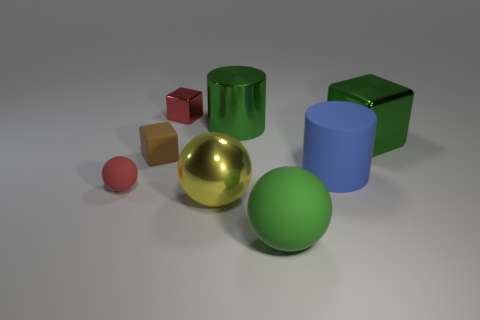Subtract all brown blocks. Subtract all brown spheres. How many blocks are left? 2 Add 2 big matte balls. How many objects exist? 10 Subtract all cubes. How many objects are left? 5 Add 7 red matte balls. How many red matte balls are left? 8 Add 4 large green metallic cylinders. How many large green metallic cylinders exist? 5 Subtract 1 red balls. How many objects are left? 7 Subtract all large blue rubber objects. Subtract all large yellow metallic balls. How many objects are left? 6 